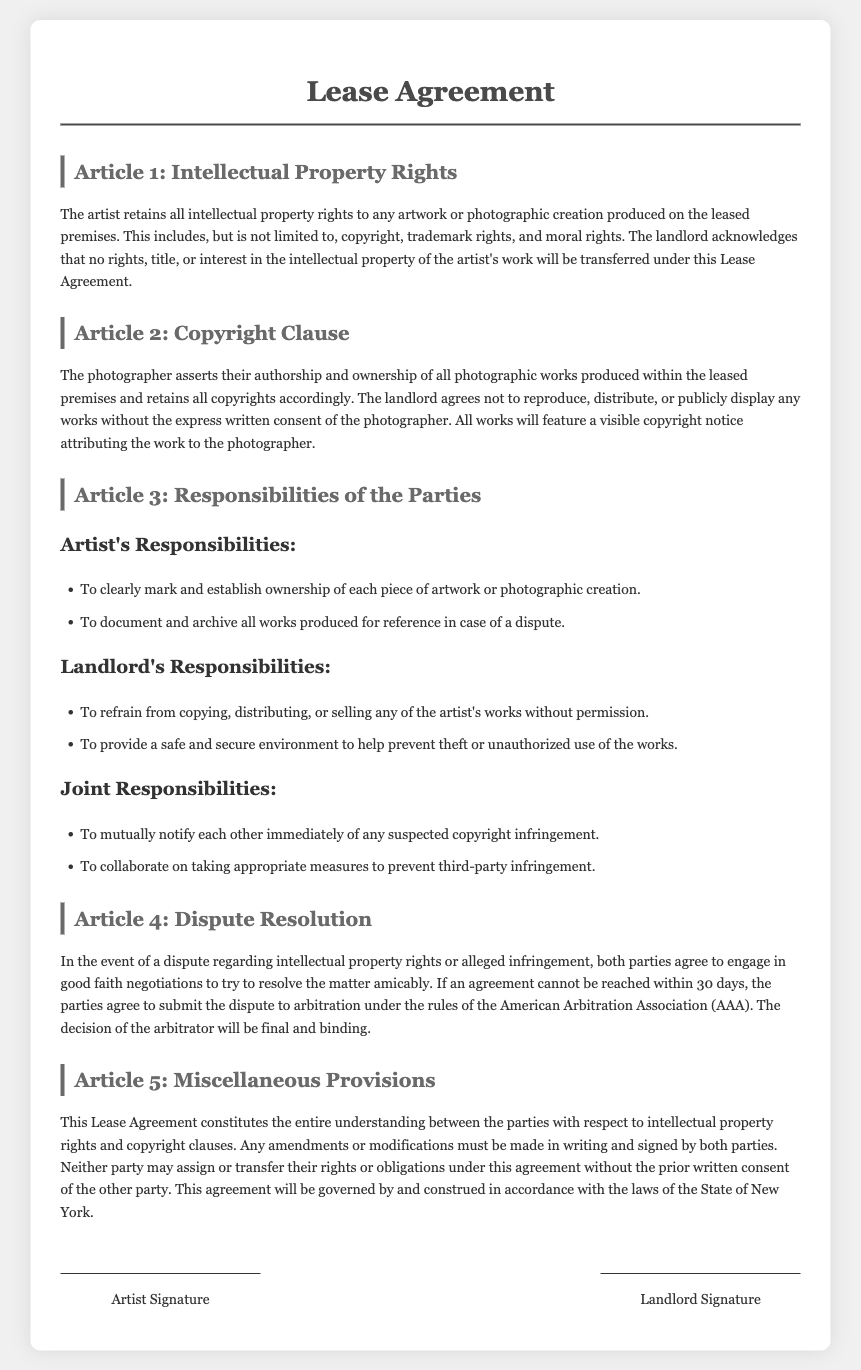What rights does the artist retain? The artist retains all intellectual property rights to any artwork or photographic creation produced on the leased premises.
Answer: Intellectual property rights What must the landlord do regarding reproduction of works? The landlord agrees not to reproduce, distribute, or publicly display any works without the express written consent of the photographer.
Answer: Not reproduce without consent What are the artist's responsibilities regarding ownership? The artist must clearly mark and establish ownership of each piece of artwork or photographic creation.
Answer: Mark ownership What kind of environment must the landlord provide? The landlord must provide a safe and secure environment to help prevent theft or unauthorized use of the works.
Answer: Safe and secure environment How long do parties have to resolve disputes through negotiation? If an agreement cannot be reached, both parties must try to resolve the matter within 30 days.
Answer: 30 days What is the governing law for this agreement? The agreement will be governed by and construed in accordance with the laws of the State of New York.
Answer: State of New York What must both parties do upon suspected copyright infringement? Both parties must mutually notify each other immediately of any suspected copyright infringement.
Answer: Notify immediately Which organization is mentioned for arbitration? The parties agree to submit disputes to arbitration under the rules of the American Arbitration Association.
Answer: American Arbitration Association What constitutes the entire understanding between the parties? This Lease Agreement constitutes the entire understanding between the parties with respect to intellectual property rights and copyright clauses.
Answer: This Lease Agreement 